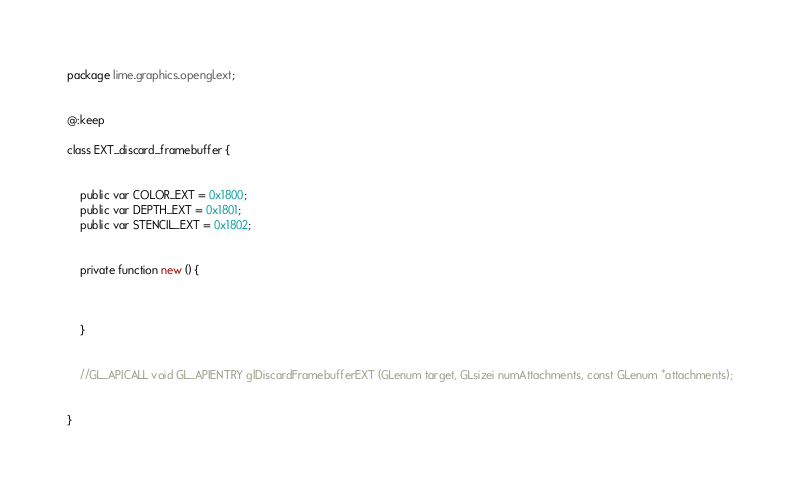Convert code to text. <code><loc_0><loc_0><loc_500><loc_500><_Haxe_>package lime.graphics.opengl.ext;


@:keep

class EXT_discard_framebuffer {
	
	
	public var COLOR_EXT = 0x1800;
	public var DEPTH_EXT = 0x1801;
	public var STENCIL_EXT = 0x1802;
	
	
	private function new () {
		
		
		
	}
	
	
	//GL_APICALL void GL_APIENTRY glDiscardFramebufferEXT (GLenum target, GLsizei numAttachments, const GLenum *attachments);
	
	
}</code> 